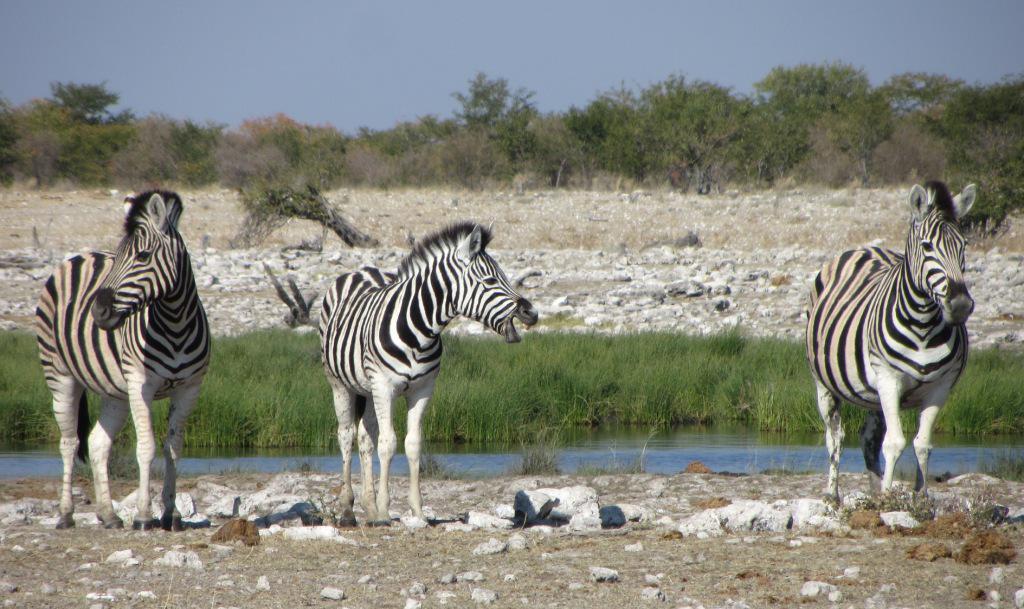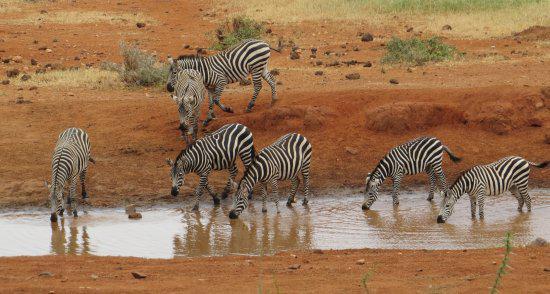The first image is the image on the left, the second image is the image on the right. Given the left and right images, does the statement "One image shows at least 8 zebras lined up close together to drink, and the other image shows a zebra and a different type of animal near a pool of water." hold true? Answer yes or no. No. The first image is the image on the left, the second image is the image on the right. Analyze the images presented: Is the assertion "The left image contains no more than three zebras." valid? Answer yes or no. Yes. 